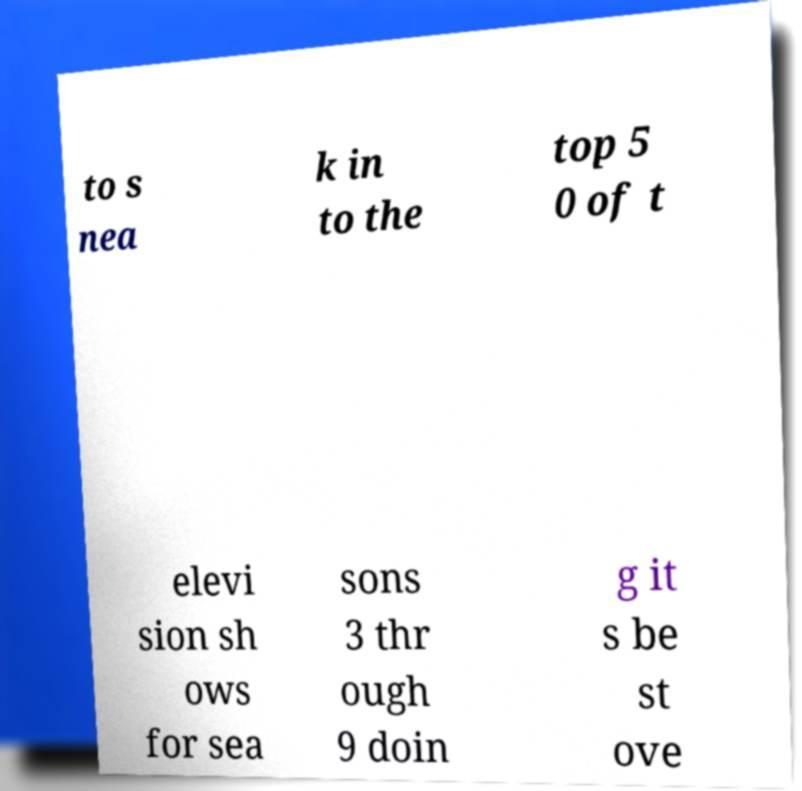I need the written content from this picture converted into text. Can you do that? to s nea k in to the top 5 0 of t elevi sion sh ows for sea sons 3 thr ough 9 doin g it s be st ove 